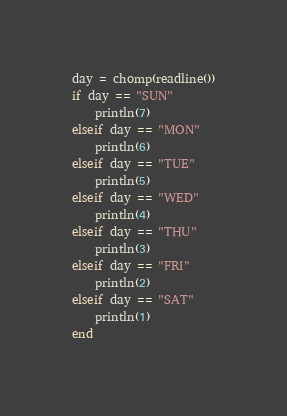Convert code to text. <code><loc_0><loc_0><loc_500><loc_500><_Julia_>
day = chomp(readline())
if day == "SUN"
    println(7)
elseif day == "MON"
    println(6)
elseif day == "TUE"
    println(5)
elseif day == "WED"
    println(4)
elseif day == "THU"
    println(3)
elseif day == "FRI"
    println(2)
elseif day == "SAT"
    println(1)
end
</code> 